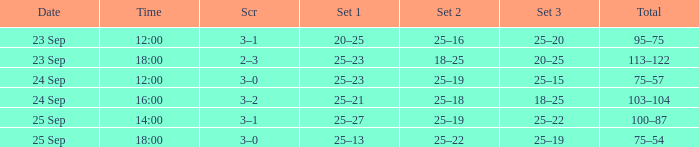What was the score when the time was 14:00? 3–1. 